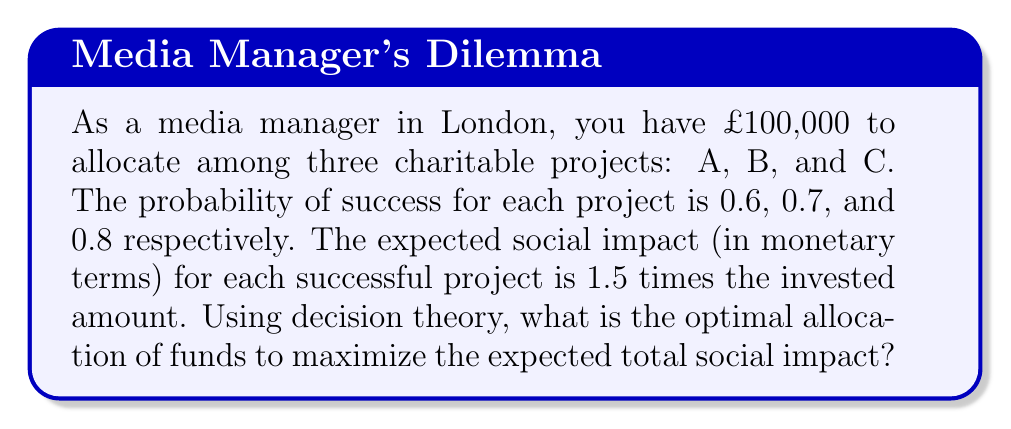Can you solve this math problem? Let's approach this step-by-step using decision theory and probability:

1) Let $x$, $y$, and $z$ be the amounts allocated to projects A, B, and C respectively.

2) The constraint equation: $x + y + z = 100,000$

3) The expected impact for each project:
   Project A: $E(A) = 0.6 \cdot 1.5x = 0.9x$
   Project B: $E(B) = 0.7 \cdot 1.5y = 1.05y$
   Project C: $E(C) = 0.8 \cdot 1.5z = 1.2z$

4) The total expected impact: $E(Total) = 0.9x + 1.05y + 1.2z$

5) To maximize $E(Total)$ subject to the constraint, we use the method of Lagrange multipliers:

   $L(x,y,z,\lambda) = 0.9x + 1.05y + 1.2z - \lambda(x + y + z - 100,000)$

6) Taking partial derivatives and setting them to zero:

   $\frac{\partial L}{\partial x} = 0.9 - \lambda = 0$
   $\frac{\partial L}{\partial y} = 1.05 - \lambda = 0$
   $\frac{\partial L}{\partial z} = 1.2 - \lambda = 0$
   $\frac{\partial L}{\partial \lambda} = x + y + z - 100,000 = 0$

7) From these equations, we can see that $\lambda = 1.2$, which means all funds should be allocated to Project C.

8) Therefore, the optimal allocation is:
   $x = 0$, $y = 0$, $z = 100,000$

9) The maximum expected total social impact is:
   $E(Total) = 1.2 \cdot 100,000 = 120,000$
Answer: Allocate all £100,000 to Project C for a maximum expected social impact of £120,000. 